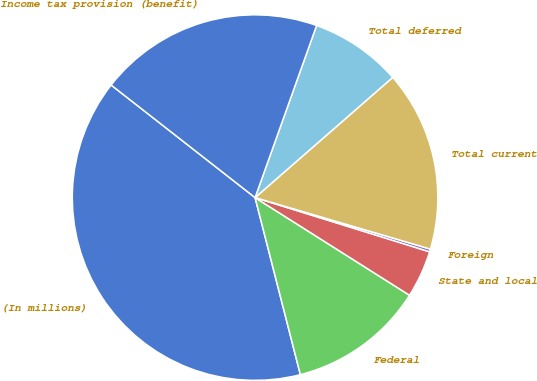Convert chart to OTSL. <chart><loc_0><loc_0><loc_500><loc_500><pie_chart><fcel>(In millions)<fcel>Federal<fcel>State and local<fcel>Foreign<fcel>Total current<fcel>Total deferred<fcel>Income tax provision (benefit)<nl><fcel>39.55%<fcel>12.04%<fcel>4.18%<fcel>0.25%<fcel>15.97%<fcel>8.11%<fcel>19.9%<nl></chart> 